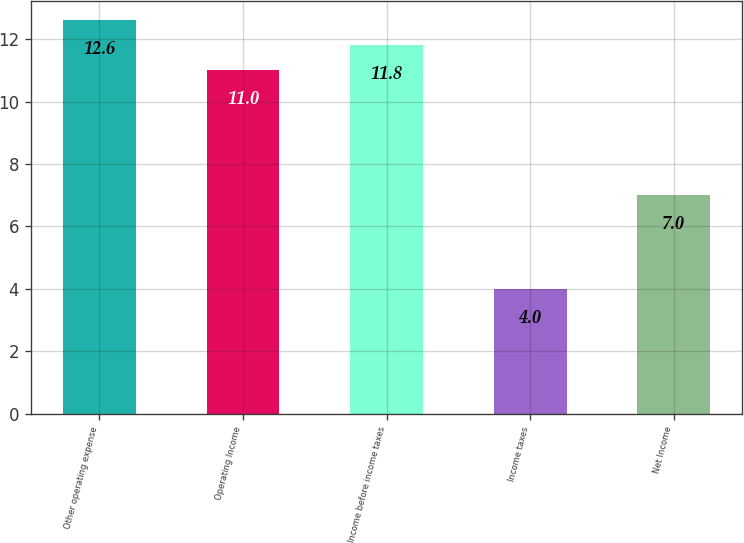<chart> <loc_0><loc_0><loc_500><loc_500><bar_chart><fcel>Other operating expense<fcel>Operating Income<fcel>Income before income taxes<fcel>Income taxes<fcel>Net Income<nl><fcel>12.6<fcel>11<fcel>11.8<fcel>4<fcel>7<nl></chart> 